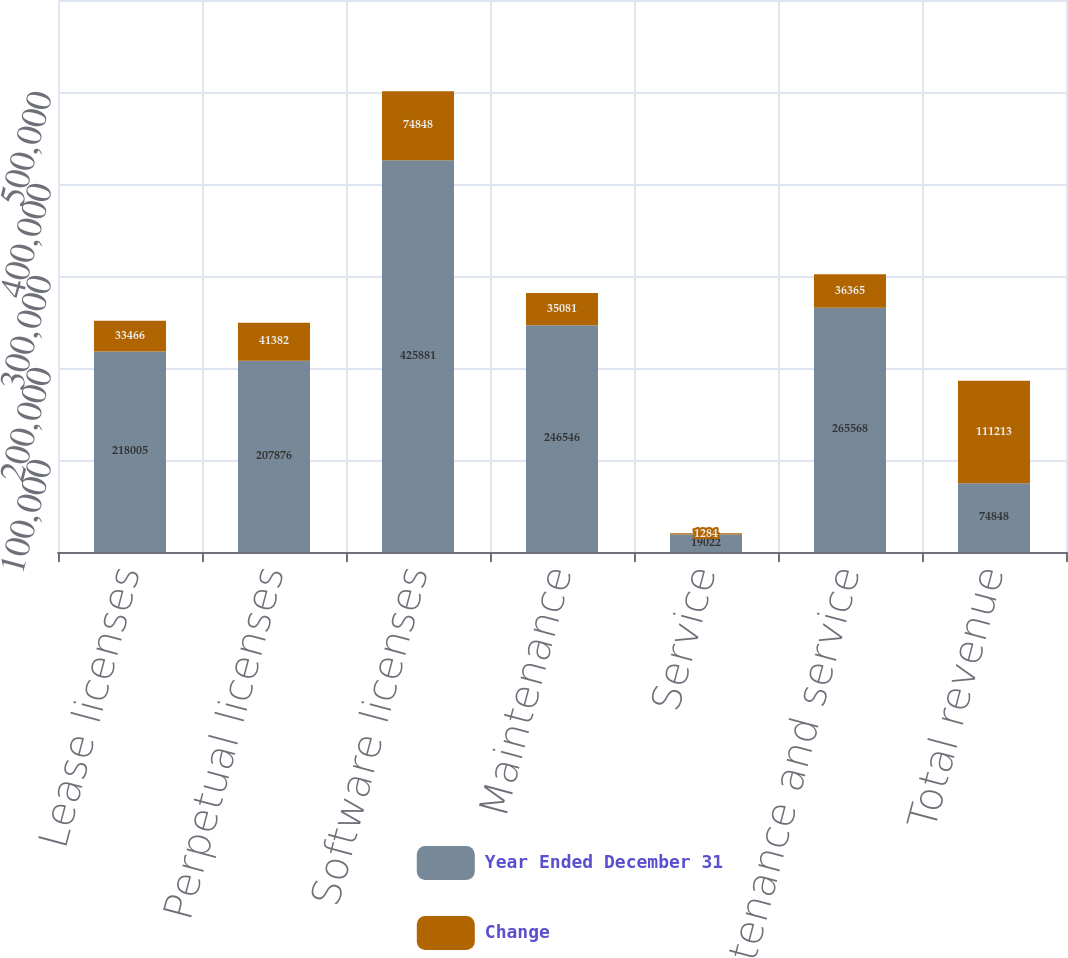Convert chart. <chart><loc_0><loc_0><loc_500><loc_500><stacked_bar_chart><ecel><fcel>Lease licenses<fcel>Perpetual licenses<fcel>Software licenses<fcel>Maintenance<fcel>Service<fcel>Maintenance and service<fcel>Total revenue<nl><fcel>Year Ended December 31<fcel>218005<fcel>207876<fcel>425881<fcel>246546<fcel>19022<fcel>265568<fcel>74848<nl><fcel>Change<fcel>33466<fcel>41382<fcel>74848<fcel>35081<fcel>1284<fcel>36365<fcel>111213<nl></chart> 